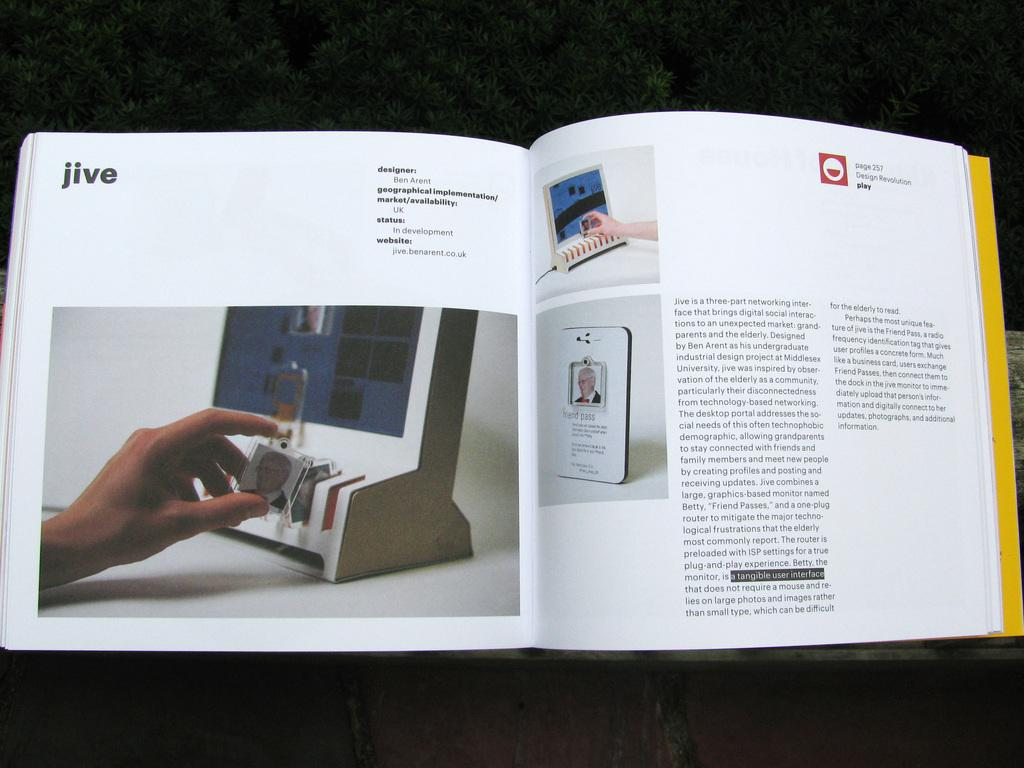<image>
Offer a succinct explanation of the picture presented. Open book showing a person holding something on page with JIVE on top. 